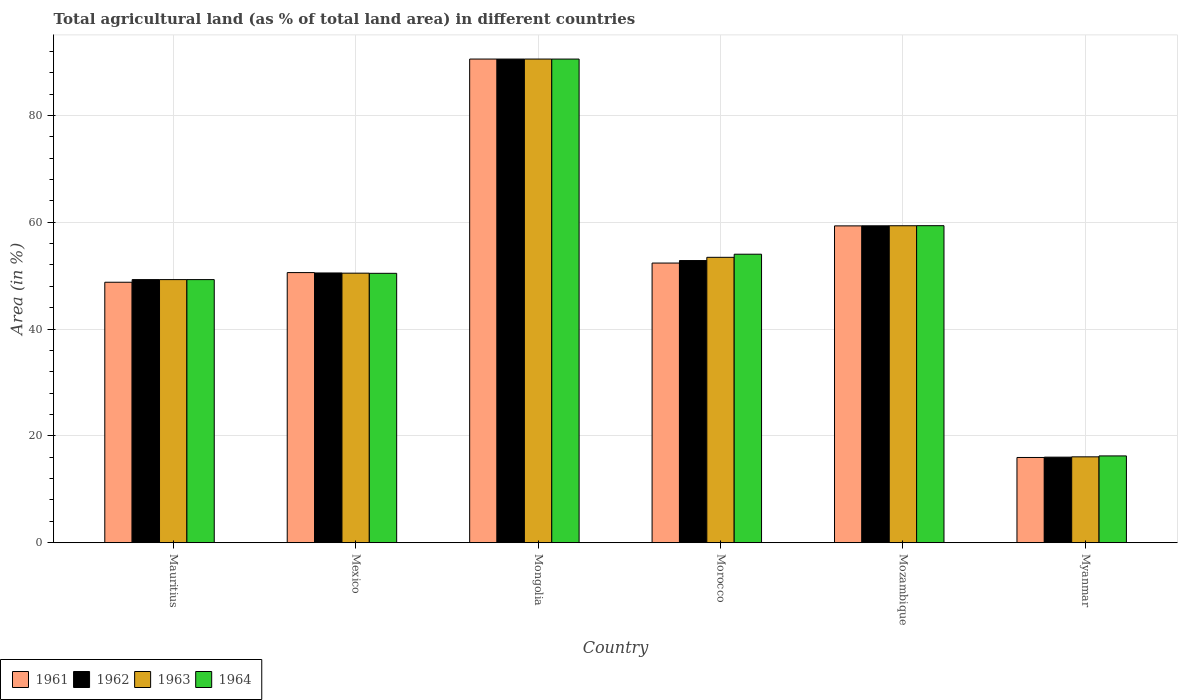How many different coloured bars are there?
Offer a terse response. 4. How many groups of bars are there?
Offer a very short reply. 6. In how many cases, is the number of bars for a given country not equal to the number of legend labels?
Give a very brief answer. 0. What is the percentage of agricultural land in 1963 in Morocco?
Offer a terse response. 53.43. Across all countries, what is the maximum percentage of agricultural land in 1964?
Offer a terse response. 90.55. Across all countries, what is the minimum percentage of agricultural land in 1962?
Give a very brief answer. 16.02. In which country was the percentage of agricultural land in 1961 maximum?
Your response must be concise. Mongolia. In which country was the percentage of agricultural land in 1962 minimum?
Your answer should be very brief. Myanmar. What is the total percentage of agricultural land in 1962 in the graph?
Your answer should be compact. 318.51. What is the difference between the percentage of agricultural land in 1961 in Mauritius and that in Mozambique?
Your response must be concise. -10.55. What is the difference between the percentage of agricultural land in 1961 in Mauritius and the percentage of agricultural land in 1962 in Mozambique?
Provide a succinct answer. -10.57. What is the average percentage of agricultural land in 1964 per country?
Your answer should be very brief. 53.31. What is the difference between the percentage of agricultural land of/in 1961 and percentage of agricultural land of/in 1962 in Mongolia?
Make the answer very short. 0. In how many countries, is the percentage of agricultural land in 1961 greater than 12 %?
Offer a terse response. 6. What is the ratio of the percentage of agricultural land in 1962 in Mauritius to that in Morocco?
Ensure brevity in your answer.  0.93. Is the percentage of agricultural land in 1962 in Mongolia less than that in Myanmar?
Provide a short and direct response. No. What is the difference between the highest and the second highest percentage of agricultural land in 1961?
Ensure brevity in your answer.  31.23. What is the difference between the highest and the lowest percentage of agricultural land in 1962?
Give a very brief answer. 74.53. In how many countries, is the percentage of agricultural land in 1962 greater than the average percentage of agricultural land in 1962 taken over all countries?
Offer a terse response. 2. Is the sum of the percentage of agricultural land in 1964 in Mauritius and Mexico greater than the maximum percentage of agricultural land in 1961 across all countries?
Offer a terse response. Yes. What does the 2nd bar from the left in Morocco represents?
Your response must be concise. 1962. What does the 3rd bar from the right in Myanmar represents?
Offer a terse response. 1962. How many countries are there in the graph?
Give a very brief answer. 6. What is the difference between two consecutive major ticks on the Y-axis?
Ensure brevity in your answer.  20. Are the values on the major ticks of Y-axis written in scientific E-notation?
Offer a very short reply. No. Does the graph contain any zero values?
Offer a terse response. No. How many legend labels are there?
Give a very brief answer. 4. How are the legend labels stacked?
Make the answer very short. Horizontal. What is the title of the graph?
Provide a short and direct response. Total agricultural land (as % of total land area) in different countries. Does "2008" appear as one of the legend labels in the graph?
Provide a succinct answer. No. What is the label or title of the X-axis?
Offer a terse response. Country. What is the label or title of the Y-axis?
Offer a terse response. Area (in %). What is the Area (in %) of 1961 in Mauritius?
Your answer should be very brief. 48.77. What is the Area (in %) in 1962 in Mauritius?
Ensure brevity in your answer.  49.26. What is the Area (in %) of 1963 in Mauritius?
Your response must be concise. 49.26. What is the Area (in %) of 1964 in Mauritius?
Offer a terse response. 49.26. What is the Area (in %) in 1961 in Mexico?
Ensure brevity in your answer.  50.58. What is the Area (in %) of 1962 in Mexico?
Provide a short and direct response. 50.5. What is the Area (in %) of 1963 in Mexico?
Give a very brief answer. 50.47. What is the Area (in %) of 1964 in Mexico?
Provide a succinct answer. 50.44. What is the Area (in %) in 1961 in Mongolia?
Provide a short and direct response. 90.56. What is the Area (in %) of 1962 in Mongolia?
Offer a terse response. 90.56. What is the Area (in %) in 1963 in Mongolia?
Offer a terse response. 90.56. What is the Area (in %) of 1964 in Mongolia?
Your answer should be compact. 90.55. What is the Area (in %) in 1961 in Morocco?
Keep it short and to the point. 52.36. What is the Area (in %) in 1962 in Morocco?
Your answer should be compact. 52.83. What is the Area (in %) in 1963 in Morocco?
Your response must be concise. 53.43. What is the Area (in %) in 1964 in Morocco?
Give a very brief answer. 54.02. What is the Area (in %) in 1961 in Mozambique?
Give a very brief answer. 59.32. What is the Area (in %) in 1962 in Mozambique?
Offer a terse response. 59.34. What is the Area (in %) in 1963 in Mozambique?
Ensure brevity in your answer.  59.35. What is the Area (in %) of 1964 in Mozambique?
Make the answer very short. 59.36. What is the Area (in %) in 1961 in Myanmar?
Ensure brevity in your answer.  15.96. What is the Area (in %) in 1962 in Myanmar?
Ensure brevity in your answer.  16.02. What is the Area (in %) of 1963 in Myanmar?
Give a very brief answer. 16.08. What is the Area (in %) in 1964 in Myanmar?
Offer a terse response. 16.25. Across all countries, what is the maximum Area (in %) of 1961?
Your response must be concise. 90.56. Across all countries, what is the maximum Area (in %) in 1962?
Your answer should be very brief. 90.56. Across all countries, what is the maximum Area (in %) of 1963?
Keep it short and to the point. 90.56. Across all countries, what is the maximum Area (in %) of 1964?
Provide a short and direct response. 90.55. Across all countries, what is the minimum Area (in %) in 1961?
Keep it short and to the point. 15.96. Across all countries, what is the minimum Area (in %) in 1962?
Make the answer very short. 16.02. Across all countries, what is the minimum Area (in %) of 1963?
Ensure brevity in your answer.  16.08. Across all countries, what is the minimum Area (in %) in 1964?
Provide a succinct answer. 16.25. What is the total Area (in %) in 1961 in the graph?
Your response must be concise. 317.54. What is the total Area (in %) in 1962 in the graph?
Offer a terse response. 318.51. What is the total Area (in %) of 1963 in the graph?
Provide a succinct answer. 319.14. What is the total Area (in %) in 1964 in the graph?
Ensure brevity in your answer.  319.88. What is the difference between the Area (in %) of 1961 in Mauritius and that in Mexico?
Your answer should be compact. -1.81. What is the difference between the Area (in %) in 1962 in Mauritius and that in Mexico?
Give a very brief answer. -1.24. What is the difference between the Area (in %) of 1963 in Mauritius and that in Mexico?
Your answer should be compact. -1.21. What is the difference between the Area (in %) in 1964 in Mauritius and that in Mexico?
Provide a short and direct response. -1.18. What is the difference between the Area (in %) of 1961 in Mauritius and that in Mongolia?
Offer a terse response. -41.79. What is the difference between the Area (in %) of 1962 in Mauritius and that in Mongolia?
Your answer should be very brief. -41.29. What is the difference between the Area (in %) of 1963 in Mauritius and that in Mongolia?
Provide a short and direct response. -41.29. What is the difference between the Area (in %) in 1964 in Mauritius and that in Mongolia?
Keep it short and to the point. -41.29. What is the difference between the Area (in %) of 1961 in Mauritius and that in Morocco?
Provide a short and direct response. -3.59. What is the difference between the Area (in %) in 1962 in Mauritius and that in Morocco?
Give a very brief answer. -3.57. What is the difference between the Area (in %) in 1963 in Mauritius and that in Morocco?
Keep it short and to the point. -4.17. What is the difference between the Area (in %) of 1964 in Mauritius and that in Morocco?
Offer a terse response. -4.76. What is the difference between the Area (in %) in 1961 in Mauritius and that in Mozambique?
Your response must be concise. -10.55. What is the difference between the Area (in %) in 1962 in Mauritius and that in Mozambique?
Keep it short and to the point. -10.07. What is the difference between the Area (in %) in 1963 in Mauritius and that in Mozambique?
Your response must be concise. -10.09. What is the difference between the Area (in %) of 1964 in Mauritius and that in Mozambique?
Offer a very short reply. -10.1. What is the difference between the Area (in %) of 1961 in Mauritius and that in Myanmar?
Your answer should be very brief. 32.81. What is the difference between the Area (in %) of 1962 in Mauritius and that in Myanmar?
Offer a terse response. 33.24. What is the difference between the Area (in %) in 1963 in Mauritius and that in Myanmar?
Offer a terse response. 33.18. What is the difference between the Area (in %) of 1964 in Mauritius and that in Myanmar?
Give a very brief answer. 33.01. What is the difference between the Area (in %) in 1961 in Mexico and that in Mongolia?
Your answer should be compact. -39.98. What is the difference between the Area (in %) in 1962 in Mexico and that in Mongolia?
Your answer should be very brief. -40.05. What is the difference between the Area (in %) of 1963 in Mexico and that in Mongolia?
Give a very brief answer. -40.09. What is the difference between the Area (in %) in 1964 in Mexico and that in Mongolia?
Your response must be concise. -40.12. What is the difference between the Area (in %) in 1961 in Mexico and that in Morocco?
Offer a terse response. -1.78. What is the difference between the Area (in %) of 1962 in Mexico and that in Morocco?
Your answer should be very brief. -2.32. What is the difference between the Area (in %) in 1963 in Mexico and that in Morocco?
Offer a terse response. -2.97. What is the difference between the Area (in %) of 1964 in Mexico and that in Morocco?
Keep it short and to the point. -3.58. What is the difference between the Area (in %) in 1961 in Mexico and that in Mozambique?
Give a very brief answer. -8.75. What is the difference between the Area (in %) of 1962 in Mexico and that in Mozambique?
Your answer should be very brief. -8.83. What is the difference between the Area (in %) in 1963 in Mexico and that in Mozambique?
Ensure brevity in your answer.  -8.88. What is the difference between the Area (in %) of 1964 in Mexico and that in Mozambique?
Your answer should be very brief. -8.92. What is the difference between the Area (in %) of 1961 in Mexico and that in Myanmar?
Your response must be concise. 34.62. What is the difference between the Area (in %) in 1962 in Mexico and that in Myanmar?
Ensure brevity in your answer.  34.48. What is the difference between the Area (in %) of 1963 in Mexico and that in Myanmar?
Offer a very short reply. 34.39. What is the difference between the Area (in %) of 1964 in Mexico and that in Myanmar?
Your response must be concise. 34.19. What is the difference between the Area (in %) in 1961 in Mongolia and that in Morocco?
Your response must be concise. 38.2. What is the difference between the Area (in %) in 1962 in Mongolia and that in Morocco?
Your response must be concise. 37.73. What is the difference between the Area (in %) in 1963 in Mongolia and that in Morocco?
Give a very brief answer. 37.12. What is the difference between the Area (in %) of 1964 in Mongolia and that in Morocco?
Provide a succinct answer. 36.54. What is the difference between the Area (in %) of 1961 in Mongolia and that in Mozambique?
Provide a short and direct response. 31.23. What is the difference between the Area (in %) of 1962 in Mongolia and that in Mozambique?
Offer a terse response. 31.22. What is the difference between the Area (in %) of 1963 in Mongolia and that in Mozambique?
Ensure brevity in your answer.  31.21. What is the difference between the Area (in %) of 1964 in Mongolia and that in Mozambique?
Make the answer very short. 31.2. What is the difference between the Area (in %) in 1961 in Mongolia and that in Myanmar?
Your answer should be very brief. 74.6. What is the difference between the Area (in %) in 1962 in Mongolia and that in Myanmar?
Offer a very short reply. 74.53. What is the difference between the Area (in %) of 1963 in Mongolia and that in Myanmar?
Your answer should be compact. 74.48. What is the difference between the Area (in %) of 1964 in Mongolia and that in Myanmar?
Your response must be concise. 74.3. What is the difference between the Area (in %) of 1961 in Morocco and that in Mozambique?
Your answer should be compact. -6.96. What is the difference between the Area (in %) in 1962 in Morocco and that in Mozambique?
Offer a terse response. -6.51. What is the difference between the Area (in %) of 1963 in Morocco and that in Mozambique?
Offer a terse response. -5.91. What is the difference between the Area (in %) in 1964 in Morocco and that in Mozambique?
Keep it short and to the point. -5.34. What is the difference between the Area (in %) in 1961 in Morocco and that in Myanmar?
Keep it short and to the point. 36.4. What is the difference between the Area (in %) of 1962 in Morocco and that in Myanmar?
Provide a succinct answer. 36.81. What is the difference between the Area (in %) of 1963 in Morocco and that in Myanmar?
Your answer should be compact. 37.36. What is the difference between the Area (in %) in 1964 in Morocco and that in Myanmar?
Your answer should be compact. 37.77. What is the difference between the Area (in %) of 1961 in Mozambique and that in Myanmar?
Ensure brevity in your answer.  43.36. What is the difference between the Area (in %) of 1962 in Mozambique and that in Myanmar?
Your answer should be very brief. 43.31. What is the difference between the Area (in %) of 1963 in Mozambique and that in Myanmar?
Keep it short and to the point. 43.27. What is the difference between the Area (in %) in 1964 in Mozambique and that in Myanmar?
Your answer should be very brief. 43.11. What is the difference between the Area (in %) in 1961 in Mauritius and the Area (in %) in 1962 in Mexico?
Your answer should be very brief. -1.74. What is the difference between the Area (in %) in 1961 in Mauritius and the Area (in %) in 1963 in Mexico?
Provide a short and direct response. -1.7. What is the difference between the Area (in %) of 1961 in Mauritius and the Area (in %) of 1964 in Mexico?
Give a very brief answer. -1.67. What is the difference between the Area (in %) of 1962 in Mauritius and the Area (in %) of 1963 in Mexico?
Keep it short and to the point. -1.21. What is the difference between the Area (in %) in 1962 in Mauritius and the Area (in %) in 1964 in Mexico?
Keep it short and to the point. -1.18. What is the difference between the Area (in %) of 1963 in Mauritius and the Area (in %) of 1964 in Mexico?
Make the answer very short. -1.18. What is the difference between the Area (in %) of 1961 in Mauritius and the Area (in %) of 1962 in Mongolia?
Give a very brief answer. -41.79. What is the difference between the Area (in %) in 1961 in Mauritius and the Area (in %) in 1963 in Mongolia?
Ensure brevity in your answer.  -41.79. What is the difference between the Area (in %) in 1961 in Mauritius and the Area (in %) in 1964 in Mongolia?
Offer a terse response. -41.79. What is the difference between the Area (in %) of 1962 in Mauritius and the Area (in %) of 1963 in Mongolia?
Provide a succinct answer. -41.29. What is the difference between the Area (in %) in 1962 in Mauritius and the Area (in %) in 1964 in Mongolia?
Your answer should be very brief. -41.29. What is the difference between the Area (in %) in 1963 in Mauritius and the Area (in %) in 1964 in Mongolia?
Your answer should be compact. -41.29. What is the difference between the Area (in %) in 1961 in Mauritius and the Area (in %) in 1962 in Morocco?
Your response must be concise. -4.06. What is the difference between the Area (in %) of 1961 in Mauritius and the Area (in %) of 1963 in Morocco?
Make the answer very short. -4.67. What is the difference between the Area (in %) of 1961 in Mauritius and the Area (in %) of 1964 in Morocco?
Offer a terse response. -5.25. What is the difference between the Area (in %) of 1962 in Mauritius and the Area (in %) of 1963 in Morocco?
Keep it short and to the point. -4.17. What is the difference between the Area (in %) of 1962 in Mauritius and the Area (in %) of 1964 in Morocco?
Your answer should be compact. -4.76. What is the difference between the Area (in %) of 1963 in Mauritius and the Area (in %) of 1964 in Morocco?
Keep it short and to the point. -4.76. What is the difference between the Area (in %) in 1961 in Mauritius and the Area (in %) in 1962 in Mozambique?
Offer a terse response. -10.57. What is the difference between the Area (in %) in 1961 in Mauritius and the Area (in %) in 1963 in Mozambique?
Offer a terse response. -10.58. What is the difference between the Area (in %) in 1961 in Mauritius and the Area (in %) in 1964 in Mozambique?
Your answer should be compact. -10.59. What is the difference between the Area (in %) in 1962 in Mauritius and the Area (in %) in 1963 in Mozambique?
Provide a short and direct response. -10.09. What is the difference between the Area (in %) in 1962 in Mauritius and the Area (in %) in 1964 in Mozambique?
Provide a succinct answer. -10.1. What is the difference between the Area (in %) in 1963 in Mauritius and the Area (in %) in 1964 in Mozambique?
Ensure brevity in your answer.  -10.1. What is the difference between the Area (in %) in 1961 in Mauritius and the Area (in %) in 1962 in Myanmar?
Your answer should be compact. 32.75. What is the difference between the Area (in %) in 1961 in Mauritius and the Area (in %) in 1963 in Myanmar?
Provide a short and direct response. 32.69. What is the difference between the Area (in %) of 1961 in Mauritius and the Area (in %) of 1964 in Myanmar?
Give a very brief answer. 32.52. What is the difference between the Area (in %) in 1962 in Mauritius and the Area (in %) in 1963 in Myanmar?
Keep it short and to the point. 33.18. What is the difference between the Area (in %) in 1962 in Mauritius and the Area (in %) in 1964 in Myanmar?
Make the answer very short. 33.01. What is the difference between the Area (in %) in 1963 in Mauritius and the Area (in %) in 1964 in Myanmar?
Offer a terse response. 33.01. What is the difference between the Area (in %) of 1961 in Mexico and the Area (in %) of 1962 in Mongolia?
Provide a short and direct response. -39.98. What is the difference between the Area (in %) of 1961 in Mexico and the Area (in %) of 1963 in Mongolia?
Make the answer very short. -39.98. What is the difference between the Area (in %) of 1961 in Mexico and the Area (in %) of 1964 in Mongolia?
Your answer should be compact. -39.98. What is the difference between the Area (in %) in 1962 in Mexico and the Area (in %) in 1963 in Mongolia?
Ensure brevity in your answer.  -40.05. What is the difference between the Area (in %) of 1962 in Mexico and the Area (in %) of 1964 in Mongolia?
Provide a short and direct response. -40.05. What is the difference between the Area (in %) in 1963 in Mexico and the Area (in %) in 1964 in Mongolia?
Give a very brief answer. -40.09. What is the difference between the Area (in %) of 1961 in Mexico and the Area (in %) of 1962 in Morocco?
Offer a very short reply. -2.25. What is the difference between the Area (in %) in 1961 in Mexico and the Area (in %) in 1963 in Morocco?
Provide a short and direct response. -2.86. What is the difference between the Area (in %) of 1961 in Mexico and the Area (in %) of 1964 in Morocco?
Offer a very short reply. -3.44. What is the difference between the Area (in %) of 1962 in Mexico and the Area (in %) of 1963 in Morocco?
Offer a terse response. -2.93. What is the difference between the Area (in %) of 1962 in Mexico and the Area (in %) of 1964 in Morocco?
Provide a succinct answer. -3.51. What is the difference between the Area (in %) of 1963 in Mexico and the Area (in %) of 1964 in Morocco?
Your answer should be very brief. -3.55. What is the difference between the Area (in %) of 1961 in Mexico and the Area (in %) of 1962 in Mozambique?
Your response must be concise. -8.76. What is the difference between the Area (in %) in 1961 in Mexico and the Area (in %) in 1963 in Mozambique?
Ensure brevity in your answer.  -8.77. What is the difference between the Area (in %) of 1961 in Mexico and the Area (in %) of 1964 in Mozambique?
Ensure brevity in your answer.  -8.78. What is the difference between the Area (in %) of 1962 in Mexico and the Area (in %) of 1963 in Mozambique?
Keep it short and to the point. -8.84. What is the difference between the Area (in %) of 1962 in Mexico and the Area (in %) of 1964 in Mozambique?
Make the answer very short. -8.85. What is the difference between the Area (in %) in 1963 in Mexico and the Area (in %) in 1964 in Mozambique?
Provide a succinct answer. -8.89. What is the difference between the Area (in %) of 1961 in Mexico and the Area (in %) of 1962 in Myanmar?
Keep it short and to the point. 34.55. What is the difference between the Area (in %) of 1961 in Mexico and the Area (in %) of 1963 in Myanmar?
Ensure brevity in your answer.  34.5. What is the difference between the Area (in %) of 1961 in Mexico and the Area (in %) of 1964 in Myanmar?
Make the answer very short. 34.33. What is the difference between the Area (in %) of 1962 in Mexico and the Area (in %) of 1963 in Myanmar?
Offer a terse response. 34.43. What is the difference between the Area (in %) of 1962 in Mexico and the Area (in %) of 1964 in Myanmar?
Provide a succinct answer. 34.25. What is the difference between the Area (in %) of 1963 in Mexico and the Area (in %) of 1964 in Myanmar?
Your answer should be compact. 34.22. What is the difference between the Area (in %) in 1961 in Mongolia and the Area (in %) in 1962 in Morocco?
Your answer should be very brief. 37.73. What is the difference between the Area (in %) in 1961 in Mongolia and the Area (in %) in 1963 in Morocco?
Make the answer very short. 37.12. What is the difference between the Area (in %) of 1961 in Mongolia and the Area (in %) of 1964 in Morocco?
Give a very brief answer. 36.54. What is the difference between the Area (in %) in 1962 in Mongolia and the Area (in %) in 1963 in Morocco?
Provide a succinct answer. 37.12. What is the difference between the Area (in %) of 1962 in Mongolia and the Area (in %) of 1964 in Morocco?
Keep it short and to the point. 36.54. What is the difference between the Area (in %) of 1963 in Mongolia and the Area (in %) of 1964 in Morocco?
Provide a succinct answer. 36.54. What is the difference between the Area (in %) in 1961 in Mongolia and the Area (in %) in 1962 in Mozambique?
Make the answer very short. 31.22. What is the difference between the Area (in %) in 1961 in Mongolia and the Area (in %) in 1963 in Mozambique?
Offer a terse response. 31.21. What is the difference between the Area (in %) of 1961 in Mongolia and the Area (in %) of 1964 in Mozambique?
Your answer should be very brief. 31.2. What is the difference between the Area (in %) in 1962 in Mongolia and the Area (in %) in 1963 in Mozambique?
Make the answer very short. 31.21. What is the difference between the Area (in %) of 1962 in Mongolia and the Area (in %) of 1964 in Mozambique?
Offer a very short reply. 31.2. What is the difference between the Area (in %) of 1963 in Mongolia and the Area (in %) of 1964 in Mozambique?
Offer a terse response. 31.2. What is the difference between the Area (in %) of 1961 in Mongolia and the Area (in %) of 1962 in Myanmar?
Your answer should be compact. 74.53. What is the difference between the Area (in %) in 1961 in Mongolia and the Area (in %) in 1963 in Myanmar?
Offer a terse response. 74.48. What is the difference between the Area (in %) in 1961 in Mongolia and the Area (in %) in 1964 in Myanmar?
Keep it short and to the point. 74.31. What is the difference between the Area (in %) in 1962 in Mongolia and the Area (in %) in 1963 in Myanmar?
Offer a very short reply. 74.48. What is the difference between the Area (in %) of 1962 in Mongolia and the Area (in %) of 1964 in Myanmar?
Your answer should be compact. 74.31. What is the difference between the Area (in %) of 1963 in Mongolia and the Area (in %) of 1964 in Myanmar?
Offer a terse response. 74.31. What is the difference between the Area (in %) of 1961 in Morocco and the Area (in %) of 1962 in Mozambique?
Provide a short and direct response. -6.98. What is the difference between the Area (in %) in 1961 in Morocco and the Area (in %) in 1963 in Mozambique?
Provide a succinct answer. -6.99. What is the difference between the Area (in %) in 1961 in Morocco and the Area (in %) in 1964 in Mozambique?
Offer a terse response. -7. What is the difference between the Area (in %) of 1962 in Morocco and the Area (in %) of 1963 in Mozambique?
Make the answer very short. -6.52. What is the difference between the Area (in %) in 1962 in Morocco and the Area (in %) in 1964 in Mozambique?
Ensure brevity in your answer.  -6.53. What is the difference between the Area (in %) of 1963 in Morocco and the Area (in %) of 1964 in Mozambique?
Ensure brevity in your answer.  -5.92. What is the difference between the Area (in %) in 1961 in Morocco and the Area (in %) in 1962 in Myanmar?
Provide a short and direct response. 36.34. What is the difference between the Area (in %) in 1961 in Morocco and the Area (in %) in 1963 in Myanmar?
Offer a very short reply. 36.28. What is the difference between the Area (in %) of 1961 in Morocco and the Area (in %) of 1964 in Myanmar?
Make the answer very short. 36.11. What is the difference between the Area (in %) in 1962 in Morocco and the Area (in %) in 1963 in Myanmar?
Provide a succinct answer. 36.75. What is the difference between the Area (in %) of 1962 in Morocco and the Area (in %) of 1964 in Myanmar?
Give a very brief answer. 36.58. What is the difference between the Area (in %) in 1963 in Morocco and the Area (in %) in 1964 in Myanmar?
Offer a very short reply. 37.18. What is the difference between the Area (in %) of 1961 in Mozambique and the Area (in %) of 1962 in Myanmar?
Keep it short and to the point. 43.3. What is the difference between the Area (in %) of 1961 in Mozambique and the Area (in %) of 1963 in Myanmar?
Your response must be concise. 43.24. What is the difference between the Area (in %) of 1961 in Mozambique and the Area (in %) of 1964 in Myanmar?
Provide a succinct answer. 43.07. What is the difference between the Area (in %) in 1962 in Mozambique and the Area (in %) in 1963 in Myanmar?
Provide a short and direct response. 43.26. What is the difference between the Area (in %) in 1962 in Mozambique and the Area (in %) in 1964 in Myanmar?
Ensure brevity in your answer.  43.09. What is the difference between the Area (in %) in 1963 in Mozambique and the Area (in %) in 1964 in Myanmar?
Provide a succinct answer. 43.1. What is the average Area (in %) in 1961 per country?
Provide a succinct answer. 52.92. What is the average Area (in %) in 1962 per country?
Give a very brief answer. 53.08. What is the average Area (in %) in 1963 per country?
Keep it short and to the point. 53.19. What is the average Area (in %) of 1964 per country?
Your response must be concise. 53.31. What is the difference between the Area (in %) of 1961 and Area (in %) of 1962 in Mauritius?
Make the answer very short. -0.49. What is the difference between the Area (in %) of 1961 and Area (in %) of 1963 in Mauritius?
Ensure brevity in your answer.  -0.49. What is the difference between the Area (in %) in 1961 and Area (in %) in 1964 in Mauritius?
Your answer should be very brief. -0.49. What is the difference between the Area (in %) of 1962 and Area (in %) of 1963 in Mauritius?
Your answer should be very brief. 0. What is the difference between the Area (in %) in 1963 and Area (in %) in 1964 in Mauritius?
Make the answer very short. 0. What is the difference between the Area (in %) in 1961 and Area (in %) in 1962 in Mexico?
Give a very brief answer. 0.07. What is the difference between the Area (in %) of 1961 and Area (in %) of 1963 in Mexico?
Your answer should be compact. 0.11. What is the difference between the Area (in %) of 1961 and Area (in %) of 1964 in Mexico?
Your answer should be compact. 0.14. What is the difference between the Area (in %) in 1962 and Area (in %) in 1963 in Mexico?
Your answer should be compact. 0.04. What is the difference between the Area (in %) in 1962 and Area (in %) in 1964 in Mexico?
Your answer should be compact. 0.07. What is the difference between the Area (in %) of 1963 and Area (in %) of 1964 in Mexico?
Give a very brief answer. 0.03. What is the difference between the Area (in %) in 1961 and Area (in %) in 1964 in Mongolia?
Offer a very short reply. 0. What is the difference between the Area (in %) in 1962 and Area (in %) in 1964 in Mongolia?
Offer a terse response. 0. What is the difference between the Area (in %) in 1963 and Area (in %) in 1964 in Mongolia?
Make the answer very short. 0. What is the difference between the Area (in %) of 1961 and Area (in %) of 1962 in Morocco?
Your answer should be compact. -0.47. What is the difference between the Area (in %) in 1961 and Area (in %) in 1963 in Morocco?
Keep it short and to the point. -1.08. What is the difference between the Area (in %) of 1961 and Area (in %) of 1964 in Morocco?
Your response must be concise. -1.66. What is the difference between the Area (in %) in 1962 and Area (in %) in 1963 in Morocco?
Your answer should be very brief. -0.6. What is the difference between the Area (in %) of 1962 and Area (in %) of 1964 in Morocco?
Provide a succinct answer. -1.19. What is the difference between the Area (in %) of 1963 and Area (in %) of 1964 in Morocco?
Provide a short and direct response. -0.58. What is the difference between the Area (in %) of 1961 and Area (in %) of 1962 in Mozambique?
Offer a terse response. -0.01. What is the difference between the Area (in %) of 1961 and Area (in %) of 1963 in Mozambique?
Give a very brief answer. -0.03. What is the difference between the Area (in %) in 1961 and Area (in %) in 1964 in Mozambique?
Offer a very short reply. -0.04. What is the difference between the Area (in %) in 1962 and Area (in %) in 1963 in Mozambique?
Ensure brevity in your answer.  -0.01. What is the difference between the Area (in %) of 1962 and Area (in %) of 1964 in Mozambique?
Your response must be concise. -0.02. What is the difference between the Area (in %) of 1963 and Area (in %) of 1964 in Mozambique?
Your response must be concise. -0.01. What is the difference between the Area (in %) in 1961 and Area (in %) in 1962 in Myanmar?
Provide a succinct answer. -0.06. What is the difference between the Area (in %) in 1961 and Area (in %) in 1963 in Myanmar?
Offer a very short reply. -0.12. What is the difference between the Area (in %) in 1961 and Area (in %) in 1964 in Myanmar?
Your response must be concise. -0.29. What is the difference between the Area (in %) of 1962 and Area (in %) of 1963 in Myanmar?
Offer a very short reply. -0.06. What is the difference between the Area (in %) of 1962 and Area (in %) of 1964 in Myanmar?
Provide a short and direct response. -0.23. What is the difference between the Area (in %) of 1963 and Area (in %) of 1964 in Myanmar?
Offer a terse response. -0.17. What is the ratio of the Area (in %) of 1961 in Mauritius to that in Mexico?
Provide a succinct answer. 0.96. What is the ratio of the Area (in %) in 1962 in Mauritius to that in Mexico?
Provide a short and direct response. 0.98. What is the ratio of the Area (in %) in 1963 in Mauritius to that in Mexico?
Your answer should be compact. 0.98. What is the ratio of the Area (in %) of 1964 in Mauritius to that in Mexico?
Your answer should be compact. 0.98. What is the ratio of the Area (in %) in 1961 in Mauritius to that in Mongolia?
Keep it short and to the point. 0.54. What is the ratio of the Area (in %) in 1962 in Mauritius to that in Mongolia?
Make the answer very short. 0.54. What is the ratio of the Area (in %) of 1963 in Mauritius to that in Mongolia?
Your answer should be compact. 0.54. What is the ratio of the Area (in %) in 1964 in Mauritius to that in Mongolia?
Your answer should be compact. 0.54. What is the ratio of the Area (in %) in 1961 in Mauritius to that in Morocco?
Make the answer very short. 0.93. What is the ratio of the Area (in %) in 1962 in Mauritius to that in Morocco?
Keep it short and to the point. 0.93. What is the ratio of the Area (in %) in 1963 in Mauritius to that in Morocco?
Your answer should be compact. 0.92. What is the ratio of the Area (in %) of 1964 in Mauritius to that in Morocco?
Your answer should be compact. 0.91. What is the ratio of the Area (in %) of 1961 in Mauritius to that in Mozambique?
Provide a short and direct response. 0.82. What is the ratio of the Area (in %) in 1962 in Mauritius to that in Mozambique?
Your answer should be very brief. 0.83. What is the ratio of the Area (in %) of 1963 in Mauritius to that in Mozambique?
Offer a terse response. 0.83. What is the ratio of the Area (in %) in 1964 in Mauritius to that in Mozambique?
Keep it short and to the point. 0.83. What is the ratio of the Area (in %) of 1961 in Mauritius to that in Myanmar?
Your answer should be very brief. 3.06. What is the ratio of the Area (in %) in 1962 in Mauritius to that in Myanmar?
Keep it short and to the point. 3.07. What is the ratio of the Area (in %) in 1963 in Mauritius to that in Myanmar?
Your answer should be compact. 3.06. What is the ratio of the Area (in %) of 1964 in Mauritius to that in Myanmar?
Make the answer very short. 3.03. What is the ratio of the Area (in %) of 1961 in Mexico to that in Mongolia?
Keep it short and to the point. 0.56. What is the ratio of the Area (in %) of 1962 in Mexico to that in Mongolia?
Make the answer very short. 0.56. What is the ratio of the Area (in %) of 1963 in Mexico to that in Mongolia?
Give a very brief answer. 0.56. What is the ratio of the Area (in %) of 1964 in Mexico to that in Mongolia?
Your answer should be very brief. 0.56. What is the ratio of the Area (in %) of 1961 in Mexico to that in Morocco?
Provide a short and direct response. 0.97. What is the ratio of the Area (in %) in 1962 in Mexico to that in Morocco?
Make the answer very short. 0.96. What is the ratio of the Area (in %) of 1963 in Mexico to that in Morocco?
Offer a terse response. 0.94. What is the ratio of the Area (in %) in 1964 in Mexico to that in Morocco?
Your answer should be compact. 0.93. What is the ratio of the Area (in %) of 1961 in Mexico to that in Mozambique?
Provide a short and direct response. 0.85. What is the ratio of the Area (in %) of 1962 in Mexico to that in Mozambique?
Give a very brief answer. 0.85. What is the ratio of the Area (in %) in 1963 in Mexico to that in Mozambique?
Your answer should be compact. 0.85. What is the ratio of the Area (in %) of 1964 in Mexico to that in Mozambique?
Make the answer very short. 0.85. What is the ratio of the Area (in %) in 1961 in Mexico to that in Myanmar?
Offer a terse response. 3.17. What is the ratio of the Area (in %) of 1962 in Mexico to that in Myanmar?
Your response must be concise. 3.15. What is the ratio of the Area (in %) of 1963 in Mexico to that in Myanmar?
Provide a succinct answer. 3.14. What is the ratio of the Area (in %) of 1964 in Mexico to that in Myanmar?
Ensure brevity in your answer.  3.1. What is the ratio of the Area (in %) in 1961 in Mongolia to that in Morocco?
Your answer should be compact. 1.73. What is the ratio of the Area (in %) of 1962 in Mongolia to that in Morocco?
Make the answer very short. 1.71. What is the ratio of the Area (in %) in 1963 in Mongolia to that in Morocco?
Keep it short and to the point. 1.69. What is the ratio of the Area (in %) in 1964 in Mongolia to that in Morocco?
Offer a very short reply. 1.68. What is the ratio of the Area (in %) of 1961 in Mongolia to that in Mozambique?
Provide a succinct answer. 1.53. What is the ratio of the Area (in %) in 1962 in Mongolia to that in Mozambique?
Make the answer very short. 1.53. What is the ratio of the Area (in %) in 1963 in Mongolia to that in Mozambique?
Make the answer very short. 1.53. What is the ratio of the Area (in %) in 1964 in Mongolia to that in Mozambique?
Give a very brief answer. 1.53. What is the ratio of the Area (in %) in 1961 in Mongolia to that in Myanmar?
Your answer should be compact. 5.67. What is the ratio of the Area (in %) in 1962 in Mongolia to that in Myanmar?
Provide a short and direct response. 5.65. What is the ratio of the Area (in %) of 1963 in Mongolia to that in Myanmar?
Your answer should be compact. 5.63. What is the ratio of the Area (in %) of 1964 in Mongolia to that in Myanmar?
Keep it short and to the point. 5.57. What is the ratio of the Area (in %) in 1961 in Morocco to that in Mozambique?
Offer a terse response. 0.88. What is the ratio of the Area (in %) of 1962 in Morocco to that in Mozambique?
Your response must be concise. 0.89. What is the ratio of the Area (in %) in 1963 in Morocco to that in Mozambique?
Provide a short and direct response. 0.9. What is the ratio of the Area (in %) of 1964 in Morocco to that in Mozambique?
Your response must be concise. 0.91. What is the ratio of the Area (in %) of 1961 in Morocco to that in Myanmar?
Provide a succinct answer. 3.28. What is the ratio of the Area (in %) in 1962 in Morocco to that in Myanmar?
Ensure brevity in your answer.  3.3. What is the ratio of the Area (in %) in 1963 in Morocco to that in Myanmar?
Offer a very short reply. 3.32. What is the ratio of the Area (in %) in 1964 in Morocco to that in Myanmar?
Provide a succinct answer. 3.32. What is the ratio of the Area (in %) in 1961 in Mozambique to that in Myanmar?
Offer a very short reply. 3.72. What is the ratio of the Area (in %) of 1962 in Mozambique to that in Myanmar?
Make the answer very short. 3.7. What is the ratio of the Area (in %) of 1963 in Mozambique to that in Myanmar?
Make the answer very short. 3.69. What is the ratio of the Area (in %) of 1964 in Mozambique to that in Myanmar?
Ensure brevity in your answer.  3.65. What is the difference between the highest and the second highest Area (in %) of 1961?
Provide a succinct answer. 31.23. What is the difference between the highest and the second highest Area (in %) of 1962?
Offer a terse response. 31.22. What is the difference between the highest and the second highest Area (in %) in 1963?
Make the answer very short. 31.21. What is the difference between the highest and the second highest Area (in %) of 1964?
Offer a terse response. 31.2. What is the difference between the highest and the lowest Area (in %) in 1961?
Offer a very short reply. 74.6. What is the difference between the highest and the lowest Area (in %) in 1962?
Your answer should be compact. 74.53. What is the difference between the highest and the lowest Area (in %) in 1963?
Make the answer very short. 74.48. What is the difference between the highest and the lowest Area (in %) in 1964?
Your answer should be very brief. 74.3. 